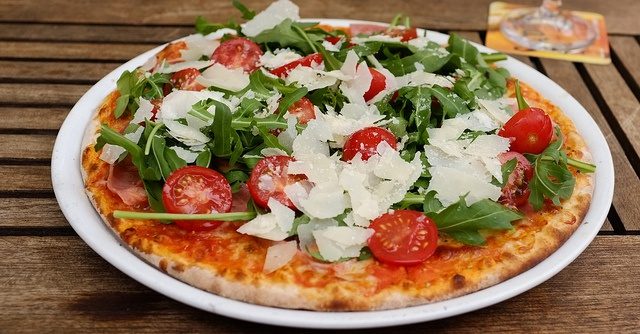Describe the objects in this image and their specific colors. I can see dining table in olive, lightgray, black, and gray tones, pizza in brown, darkgreen, and lightgray tones, and wine glass in brown, tan, and darkgray tones in this image. 